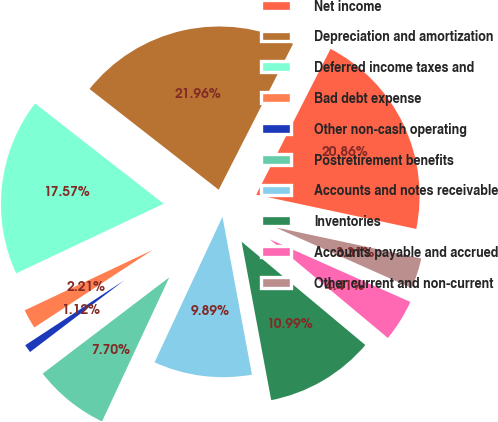Convert chart. <chart><loc_0><loc_0><loc_500><loc_500><pie_chart><fcel>Net income<fcel>Depreciation and amortization<fcel>Deferred income taxes and<fcel>Bad debt expense<fcel>Other non-cash operating<fcel>Postretirement benefits<fcel>Accounts and notes receivable<fcel>Inventories<fcel>Accounts payable and accrued<fcel>Other current and non-current<nl><fcel>20.86%<fcel>21.96%<fcel>17.57%<fcel>2.21%<fcel>1.12%<fcel>7.7%<fcel>9.89%<fcel>10.99%<fcel>4.41%<fcel>3.31%<nl></chart> 